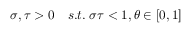Convert formula to latex. <formula><loc_0><loc_0><loc_500><loc_500>\sigma , \tau > 0 \quad s . t . \, \sigma \tau < 1 , \theta \in [ 0 , 1 ]</formula> 